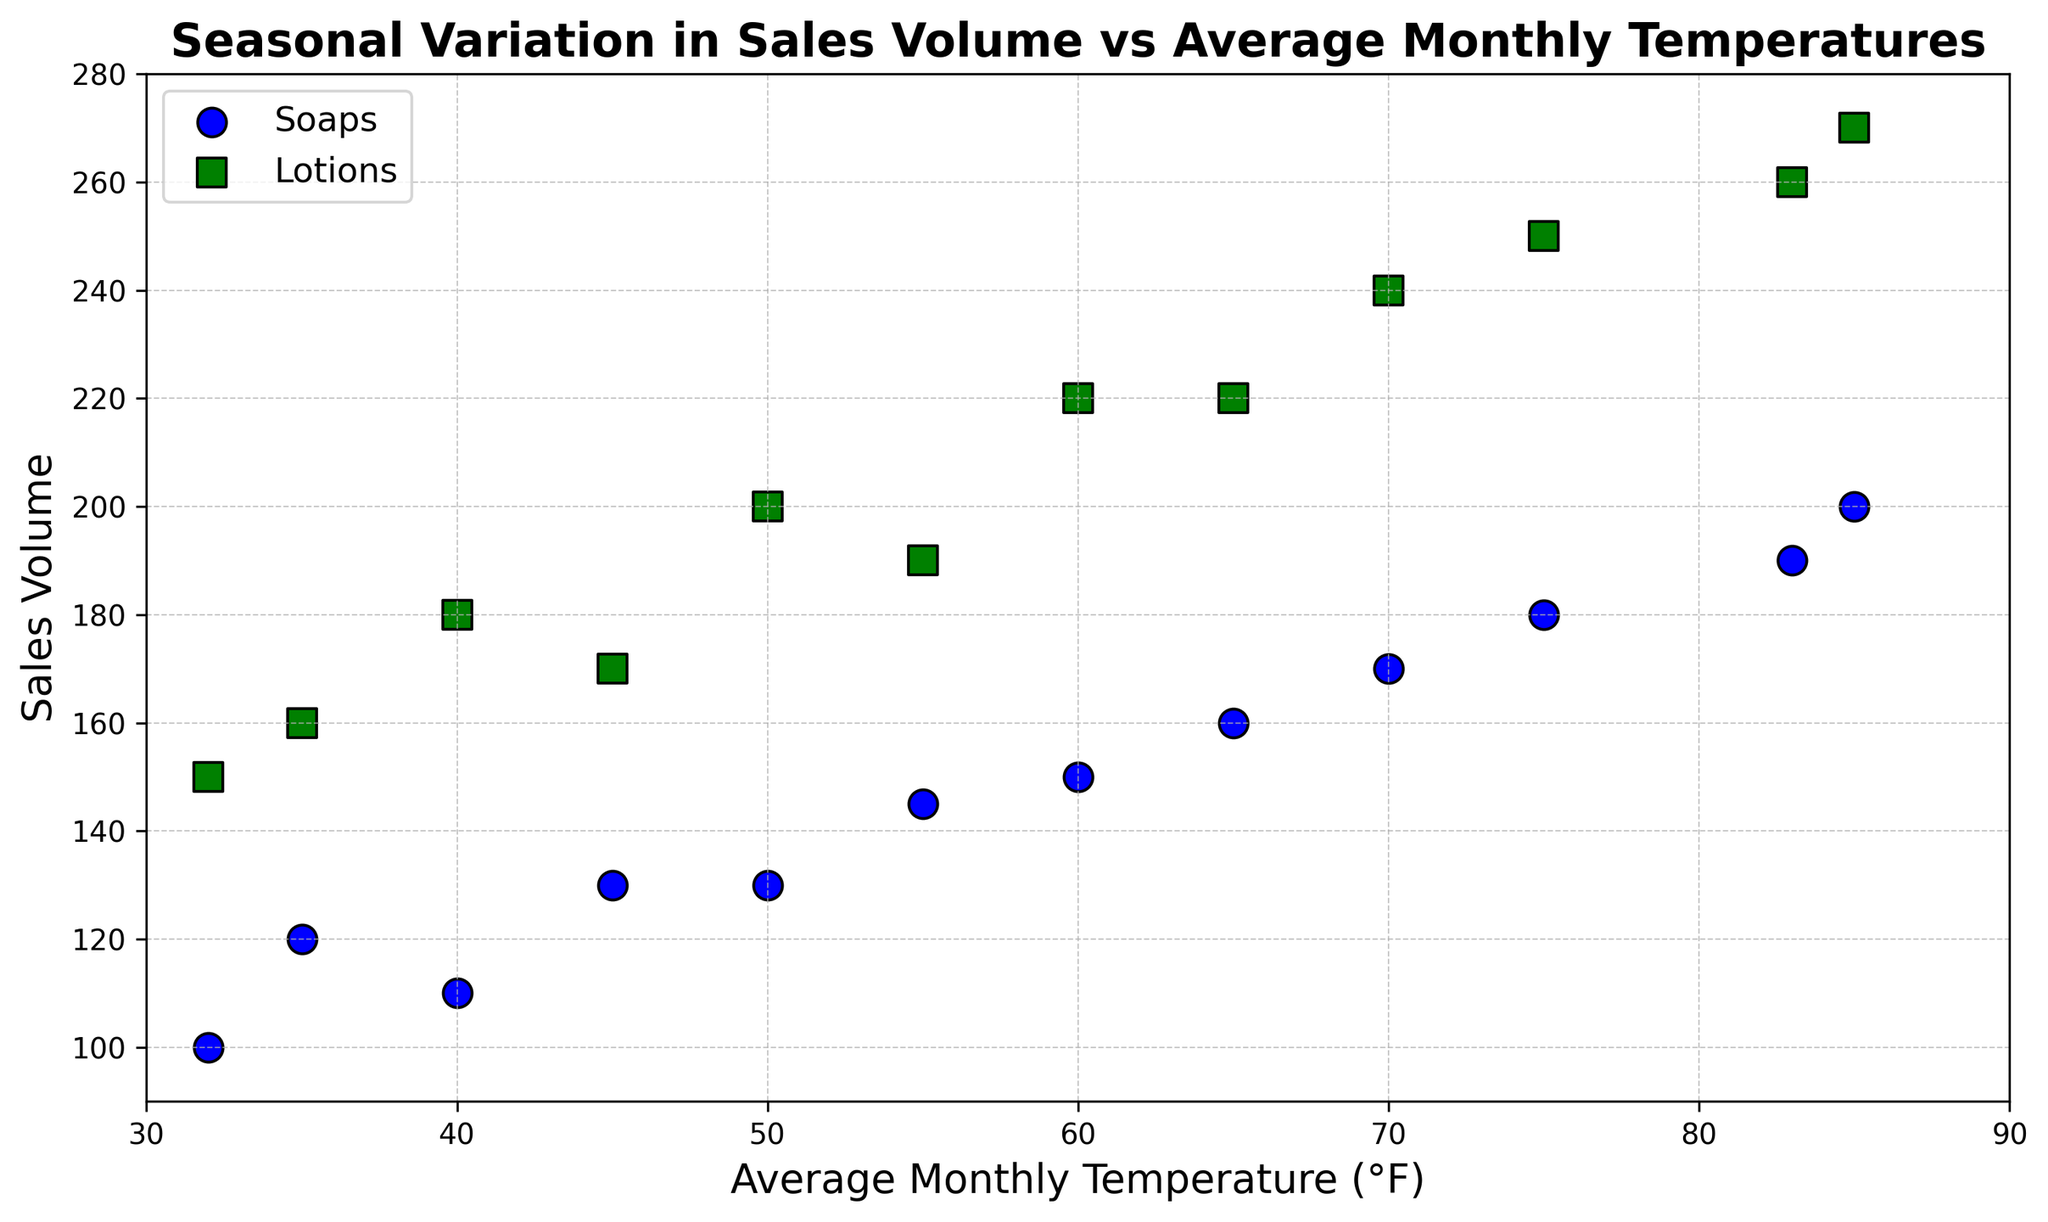What is the sales volume of soaps when the temperature is 75°F? Locate the point where the Average Temperature is 75°F (June). The corresponding Sales Volume for soaps is 180.
Answer: 180 Which month has the highest sales volume for lotions and what is that volume? From the scatter plot, identify the highest point for lotions marked 's' (green) and correlate it to the corresponding month (July). The highest sales volume for lotions is 270 in July.
Answer: July, 270 How does the sales volume for soaps compare between January and July? Compare the two points on the scatter plot at Average Temperatures 32°F (January) and 85°F (July) for soaps. The Sales Volume for soaps in January is 100, and in July it is 200.
Answer: January: 100, July: 200 What is the difference in sales volume of lotions between April and August? For Lotions, locate the points for April (55°F) and August (83°F) on the scatter plot. The Sales Volume for lotions in April is 190, and in August it is 260. The difference is 260 - 190.
Answer: 70 What is the average sales volume of lotions between March and June inclusive? Identify the Sales Volume for lotions for March (170), April (190), May (220), and June (250). Calculate the average: (170 + 190 + 220 + 250) / 4 = 830 / 4.
Answer: 207.5 During which month do soaps and lotions both have their lowest sales volume, and what are those volumes? Identify the smallest values in both Sales Volume Soaps and Sales Volume Lotions. For Lotions, the lowest value is 150, and for Soaps, the lowest is 100, both occurring in January.
Answer: January, Soaps: 100, Lotions: 150 Which month shows a decreasing trend in sales volume for both soaps and lotions compared to the previous month? Look for points where the sales volumes of both soaps and lotions decreased compared to the previous month's values. From August to September, Soaps decreased from 190 to 170 and Lotions from 260 to 240.
Answer: September Is there any month where the sales volume of soaps is higher than lotions? Compare the Sales Volume for soaps and lotions for each month. There is no instance where the volume of soaps is higher than that of lotions.
Answer: No How does the sales volume of lotions in February compare to October? Identify the points for February (160) and October (220) for lotions. February has a sales volume of 160, while October has 220.
Answer: February: 160, October: 220 What is the total sales volume for soaps for the whole year? Sum the Sales Volume of soaps for each month: 100 + 120 + 130 + 145 + 160 + 180 + 200 + 190 + 170 + 150 + 130 + 110 = 1685.
Answer: 1685 